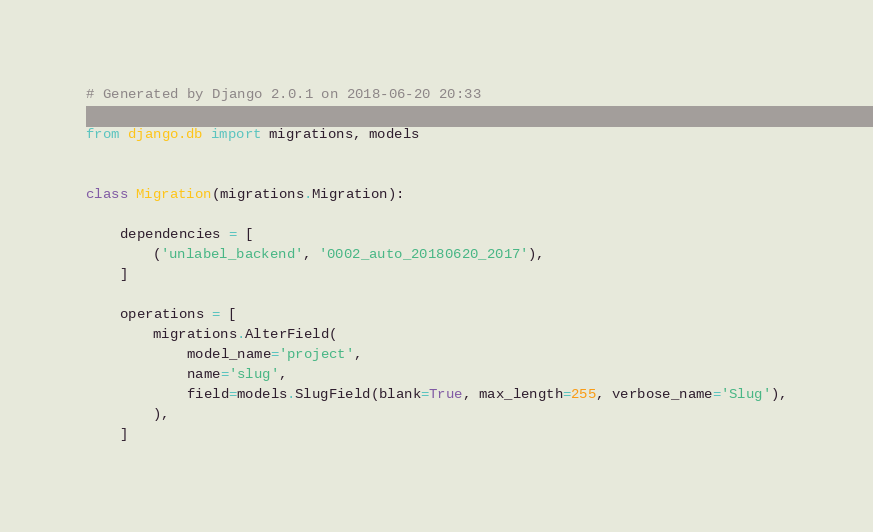<code> <loc_0><loc_0><loc_500><loc_500><_Python_># Generated by Django 2.0.1 on 2018-06-20 20:33

from django.db import migrations, models


class Migration(migrations.Migration):

    dependencies = [
        ('unlabel_backend', '0002_auto_20180620_2017'),
    ]

    operations = [
        migrations.AlterField(
            model_name='project',
            name='slug',
            field=models.SlugField(blank=True, max_length=255, verbose_name='Slug'),
        ),
    ]
</code> 